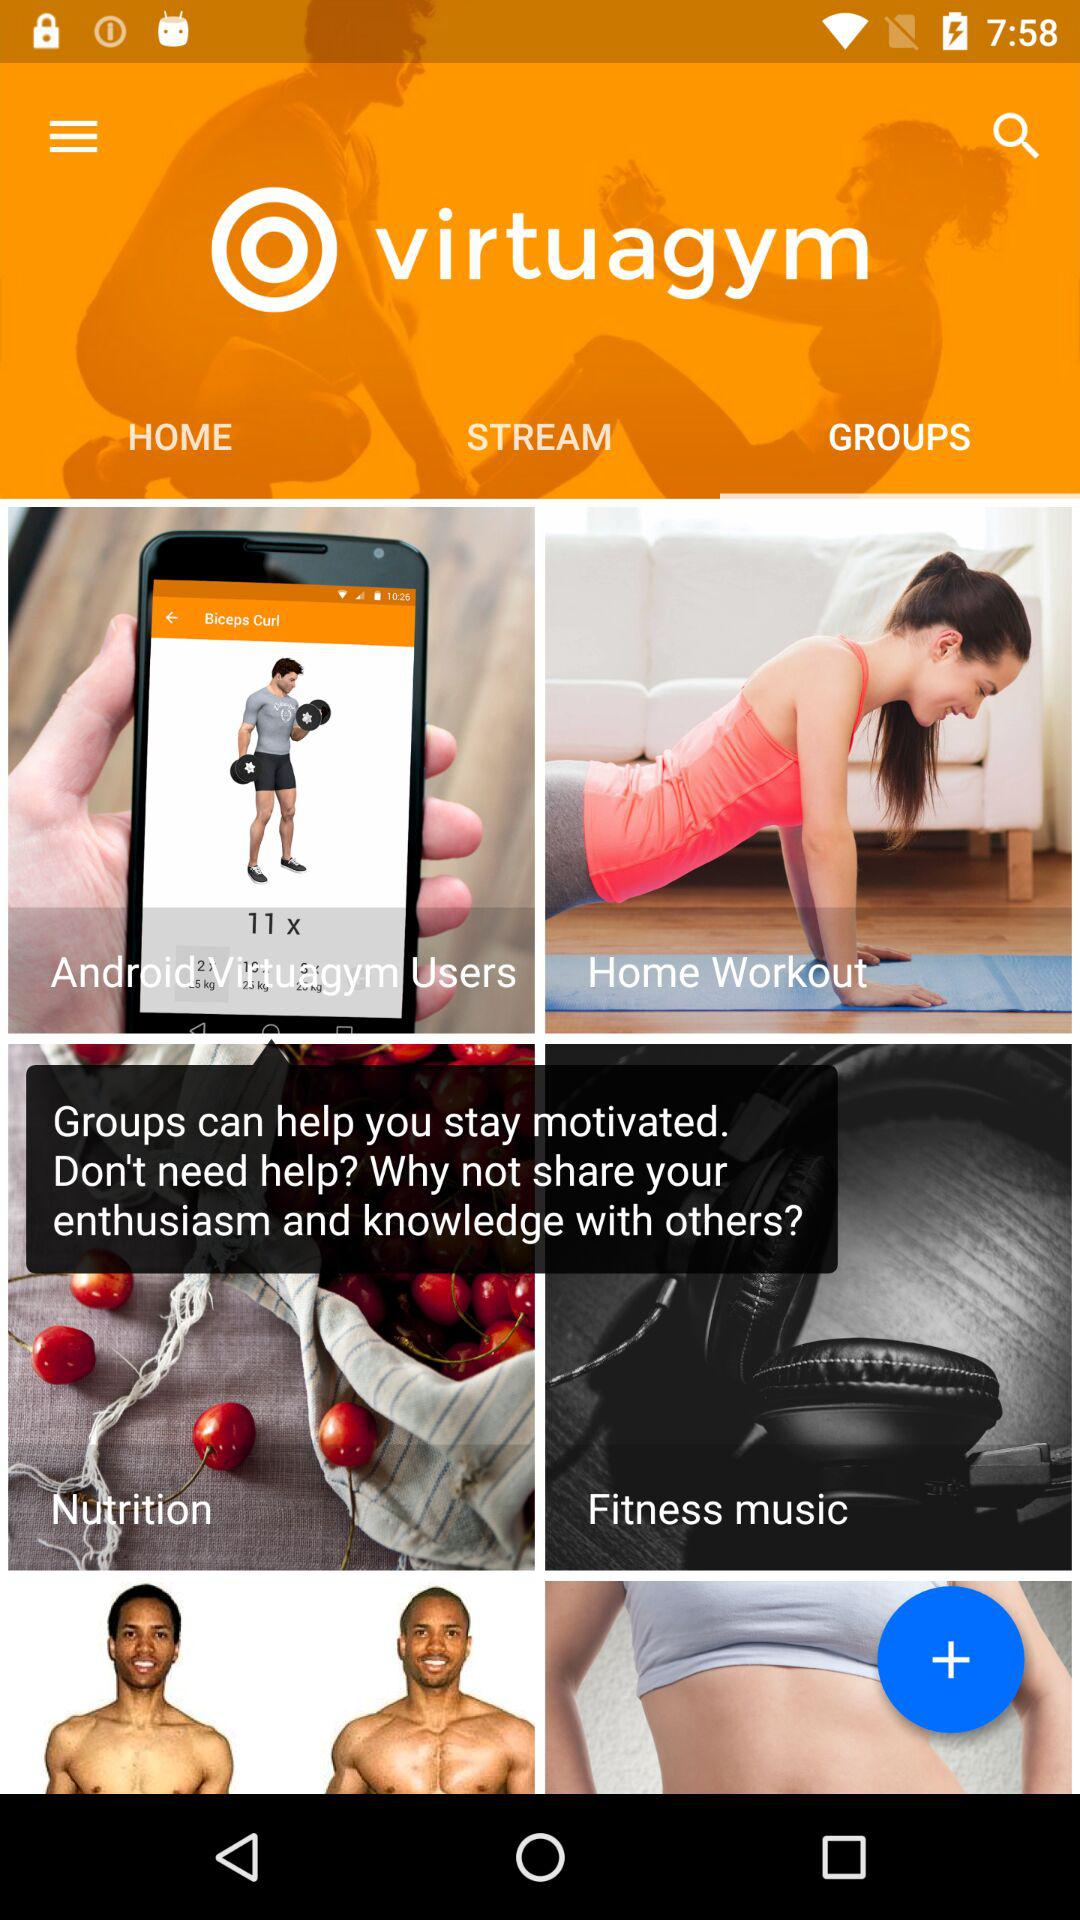Which tab is selected? The selected tab is "GROUPS". 